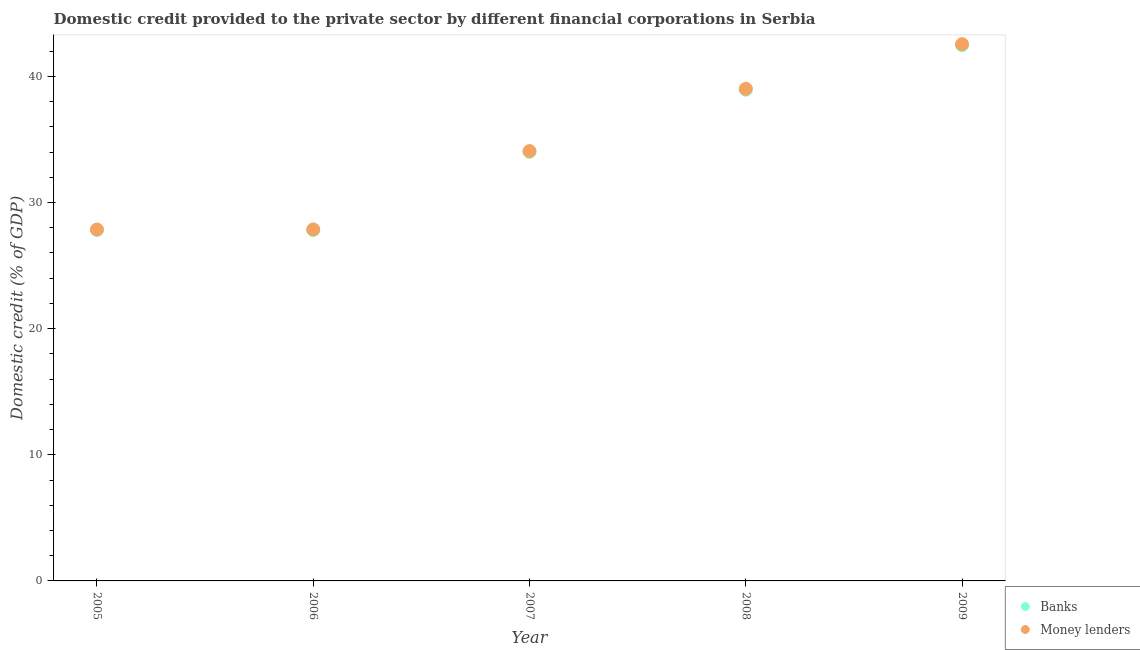How many different coloured dotlines are there?
Keep it short and to the point. 2. What is the domestic credit provided by banks in 2007?
Offer a terse response. 34.01. Across all years, what is the maximum domestic credit provided by money lenders?
Give a very brief answer. 42.55. Across all years, what is the minimum domestic credit provided by banks?
Provide a short and direct response. 27.81. In which year was the domestic credit provided by banks maximum?
Your answer should be compact. 2009. In which year was the domestic credit provided by money lenders minimum?
Provide a short and direct response. 2005. What is the total domestic credit provided by banks in the graph?
Your answer should be compact. 171.06. What is the difference between the domestic credit provided by banks in 2008 and that in 2009?
Your answer should be compact. -3.52. What is the difference between the domestic credit provided by money lenders in 2008 and the domestic credit provided by banks in 2009?
Offer a very short reply. -3.45. What is the average domestic credit provided by banks per year?
Offer a very short reply. 34.21. In the year 2008, what is the difference between the domestic credit provided by money lenders and domestic credit provided by banks?
Offer a very short reply. 0.07. In how many years, is the domestic credit provided by money lenders greater than 32 %?
Ensure brevity in your answer.  3. What is the ratio of the domestic credit provided by money lenders in 2007 to that in 2009?
Offer a terse response. 0.8. Is the domestic credit provided by money lenders in 2006 less than that in 2009?
Provide a succinct answer. Yes. Is the difference between the domestic credit provided by money lenders in 2006 and 2009 greater than the difference between the domestic credit provided by banks in 2006 and 2009?
Your response must be concise. No. What is the difference between the highest and the second highest domestic credit provided by money lenders?
Provide a succinct answer. 3.54. What is the difference between the highest and the lowest domestic credit provided by money lenders?
Offer a terse response. 14.69. In how many years, is the domestic credit provided by money lenders greater than the average domestic credit provided by money lenders taken over all years?
Your answer should be very brief. 2. Is the domestic credit provided by money lenders strictly less than the domestic credit provided by banks over the years?
Keep it short and to the point. No. How many dotlines are there?
Provide a succinct answer. 2. What is the difference between two consecutive major ticks on the Y-axis?
Give a very brief answer. 10. Are the values on the major ticks of Y-axis written in scientific E-notation?
Ensure brevity in your answer.  No. Does the graph contain grids?
Ensure brevity in your answer.  No. Where does the legend appear in the graph?
Make the answer very short. Bottom right. How many legend labels are there?
Offer a very short reply. 2. How are the legend labels stacked?
Your answer should be compact. Vertical. What is the title of the graph?
Your answer should be compact. Domestic credit provided to the private sector by different financial corporations in Serbia. Does "Drinking water services" appear as one of the legend labels in the graph?
Make the answer very short. No. What is the label or title of the Y-axis?
Offer a terse response. Domestic credit (% of GDP). What is the Domestic credit (% of GDP) in Banks in 2005?
Your response must be concise. 27.83. What is the Domestic credit (% of GDP) of Money lenders in 2005?
Your answer should be very brief. 27.86. What is the Domestic credit (% of GDP) of Banks in 2006?
Provide a short and direct response. 27.81. What is the Domestic credit (% of GDP) in Money lenders in 2006?
Your answer should be compact. 27.86. What is the Domestic credit (% of GDP) in Banks in 2007?
Offer a very short reply. 34.01. What is the Domestic credit (% of GDP) in Money lenders in 2007?
Provide a short and direct response. 34.08. What is the Domestic credit (% of GDP) of Banks in 2008?
Give a very brief answer. 38.94. What is the Domestic credit (% of GDP) of Money lenders in 2008?
Give a very brief answer. 39.01. What is the Domestic credit (% of GDP) in Banks in 2009?
Keep it short and to the point. 42.46. What is the Domestic credit (% of GDP) of Money lenders in 2009?
Your response must be concise. 42.55. Across all years, what is the maximum Domestic credit (% of GDP) in Banks?
Your response must be concise. 42.46. Across all years, what is the maximum Domestic credit (% of GDP) of Money lenders?
Your answer should be compact. 42.55. Across all years, what is the minimum Domestic credit (% of GDP) of Banks?
Offer a terse response. 27.81. Across all years, what is the minimum Domestic credit (% of GDP) in Money lenders?
Provide a succinct answer. 27.86. What is the total Domestic credit (% of GDP) in Banks in the graph?
Your answer should be compact. 171.06. What is the total Domestic credit (% of GDP) of Money lenders in the graph?
Make the answer very short. 171.36. What is the difference between the Domestic credit (% of GDP) of Banks in 2005 and that in 2006?
Provide a short and direct response. 0.02. What is the difference between the Domestic credit (% of GDP) in Money lenders in 2005 and that in 2006?
Provide a short and direct response. -0.01. What is the difference between the Domestic credit (% of GDP) in Banks in 2005 and that in 2007?
Your answer should be very brief. -6.19. What is the difference between the Domestic credit (% of GDP) of Money lenders in 2005 and that in 2007?
Your response must be concise. -6.22. What is the difference between the Domestic credit (% of GDP) in Banks in 2005 and that in 2008?
Offer a terse response. -11.11. What is the difference between the Domestic credit (% of GDP) in Money lenders in 2005 and that in 2008?
Provide a short and direct response. -11.15. What is the difference between the Domestic credit (% of GDP) of Banks in 2005 and that in 2009?
Make the answer very short. -14.64. What is the difference between the Domestic credit (% of GDP) of Money lenders in 2005 and that in 2009?
Your answer should be compact. -14.69. What is the difference between the Domestic credit (% of GDP) of Banks in 2006 and that in 2007?
Your answer should be compact. -6.21. What is the difference between the Domestic credit (% of GDP) in Money lenders in 2006 and that in 2007?
Your response must be concise. -6.21. What is the difference between the Domestic credit (% of GDP) of Banks in 2006 and that in 2008?
Keep it short and to the point. -11.13. What is the difference between the Domestic credit (% of GDP) in Money lenders in 2006 and that in 2008?
Give a very brief answer. -11.15. What is the difference between the Domestic credit (% of GDP) in Banks in 2006 and that in 2009?
Give a very brief answer. -14.66. What is the difference between the Domestic credit (% of GDP) in Money lenders in 2006 and that in 2009?
Your answer should be very brief. -14.69. What is the difference between the Domestic credit (% of GDP) in Banks in 2007 and that in 2008?
Ensure brevity in your answer.  -4.93. What is the difference between the Domestic credit (% of GDP) of Money lenders in 2007 and that in 2008?
Keep it short and to the point. -4.93. What is the difference between the Domestic credit (% of GDP) in Banks in 2007 and that in 2009?
Provide a short and direct response. -8.45. What is the difference between the Domestic credit (% of GDP) in Money lenders in 2007 and that in 2009?
Offer a very short reply. -8.47. What is the difference between the Domestic credit (% of GDP) in Banks in 2008 and that in 2009?
Make the answer very short. -3.52. What is the difference between the Domestic credit (% of GDP) of Money lenders in 2008 and that in 2009?
Provide a succinct answer. -3.54. What is the difference between the Domestic credit (% of GDP) in Banks in 2005 and the Domestic credit (% of GDP) in Money lenders in 2006?
Provide a succinct answer. -0.03. What is the difference between the Domestic credit (% of GDP) in Banks in 2005 and the Domestic credit (% of GDP) in Money lenders in 2007?
Your response must be concise. -6.25. What is the difference between the Domestic credit (% of GDP) of Banks in 2005 and the Domestic credit (% of GDP) of Money lenders in 2008?
Offer a terse response. -11.18. What is the difference between the Domestic credit (% of GDP) in Banks in 2005 and the Domestic credit (% of GDP) in Money lenders in 2009?
Your response must be concise. -14.72. What is the difference between the Domestic credit (% of GDP) of Banks in 2006 and the Domestic credit (% of GDP) of Money lenders in 2007?
Keep it short and to the point. -6.27. What is the difference between the Domestic credit (% of GDP) in Banks in 2006 and the Domestic credit (% of GDP) in Money lenders in 2008?
Your answer should be very brief. -11.2. What is the difference between the Domestic credit (% of GDP) of Banks in 2006 and the Domestic credit (% of GDP) of Money lenders in 2009?
Provide a short and direct response. -14.74. What is the difference between the Domestic credit (% of GDP) in Banks in 2007 and the Domestic credit (% of GDP) in Money lenders in 2008?
Your answer should be very brief. -5. What is the difference between the Domestic credit (% of GDP) of Banks in 2007 and the Domestic credit (% of GDP) of Money lenders in 2009?
Your answer should be very brief. -8.53. What is the difference between the Domestic credit (% of GDP) in Banks in 2008 and the Domestic credit (% of GDP) in Money lenders in 2009?
Your response must be concise. -3.61. What is the average Domestic credit (% of GDP) in Banks per year?
Provide a short and direct response. 34.21. What is the average Domestic credit (% of GDP) of Money lenders per year?
Offer a very short reply. 34.27. In the year 2005, what is the difference between the Domestic credit (% of GDP) in Banks and Domestic credit (% of GDP) in Money lenders?
Provide a short and direct response. -0.03. In the year 2006, what is the difference between the Domestic credit (% of GDP) in Banks and Domestic credit (% of GDP) in Money lenders?
Offer a terse response. -0.05. In the year 2007, what is the difference between the Domestic credit (% of GDP) of Banks and Domestic credit (% of GDP) of Money lenders?
Offer a very short reply. -0.06. In the year 2008, what is the difference between the Domestic credit (% of GDP) in Banks and Domestic credit (% of GDP) in Money lenders?
Offer a very short reply. -0.07. In the year 2009, what is the difference between the Domestic credit (% of GDP) of Banks and Domestic credit (% of GDP) of Money lenders?
Your answer should be compact. -0.09. What is the ratio of the Domestic credit (% of GDP) in Money lenders in 2005 to that in 2006?
Keep it short and to the point. 1. What is the ratio of the Domestic credit (% of GDP) of Banks in 2005 to that in 2007?
Offer a very short reply. 0.82. What is the ratio of the Domestic credit (% of GDP) in Money lenders in 2005 to that in 2007?
Keep it short and to the point. 0.82. What is the ratio of the Domestic credit (% of GDP) in Banks in 2005 to that in 2008?
Keep it short and to the point. 0.71. What is the ratio of the Domestic credit (% of GDP) in Money lenders in 2005 to that in 2008?
Offer a terse response. 0.71. What is the ratio of the Domestic credit (% of GDP) in Banks in 2005 to that in 2009?
Provide a succinct answer. 0.66. What is the ratio of the Domestic credit (% of GDP) of Money lenders in 2005 to that in 2009?
Provide a short and direct response. 0.65. What is the ratio of the Domestic credit (% of GDP) in Banks in 2006 to that in 2007?
Give a very brief answer. 0.82. What is the ratio of the Domestic credit (% of GDP) in Money lenders in 2006 to that in 2007?
Offer a terse response. 0.82. What is the ratio of the Domestic credit (% of GDP) in Banks in 2006 to that in 2008?
Ensure brevity in your answer.  0.71. What is the ratio of the Domestic credit (% of GDP) of Money lenders in 2006 to that in 2008?
Offer a very short reply. 0.71. What is the ratio of the Domestic credit (% of GDP) in Banks in 2006 to that in 2009?
Your answer should be compact. 0.65. What is the ratio of the Domestic credit (% of GDP) of Money lenders in 2006 to that in 2009?
Your answer should be very brief. 0.65. What is the ratio of the Domestic credit (% of GDP) in Banks in 2007 to that in 2008?
Your answer should be very brief. 0.87. What is the ratio of the Domestic credit (% of GDP) in Money lenders in 2007 to that in 2008?
Your response must be concise. 0.87. What is the ratio of the Domestic credit (% of GDP) in Banks in 2007 to that in 2009?
Offer a terse response. 0.8. What is the ratio of the Domestic credit (% of GDP) in Money lenders in 2007 to that in 2009?
Offer a terse response. 0.8. What is the ratio of the Domestic credit (% of GDP) of Banks in 2008 to that in 2009?
Give a very brief answer. 0.92. What is the ratio of the Domestic credit (% of GDP) in Money lenders in 2008 to that in 2009?
Ensure brevity in your answer.  0.92. What is the difference between the highest and the second highest Domestic credit (% of GDP) in Banks?
Offer a very short reply. 3.52. What is the difference between the highest and the second highest Domestic credit (% of GDP) of Money lenders?
Your answer should be compact. 3.54. What is the difference between the highest and the lowest Domestic credit (% of GDP) of Banks?
Make the answer very short. 14.66. What is the difference between the highest and the lowest Domestic credit (% of GDP) in Money lenders?
Make the answer very short. 14.69. 